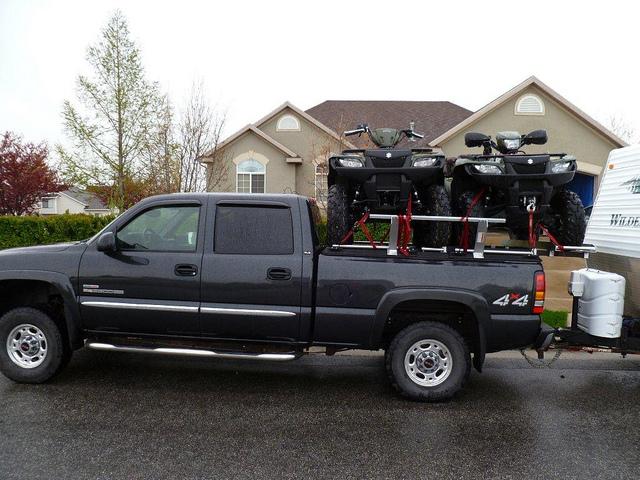What color is the pickup truck?
Quick response, please. Black. What color is the stripe on the side of the truck?
Keep it brief. Silver. What hometown event might this truck have been in?
Quick response, please. Parade. What do they use to unload the quads?
Short answer required. Ramp. What color is the vehicle?
Quick response, please. Black. Is this a new truck?
Be succinct. Yes. Is this a recent model?
Write a very short answer. Yes. What is the truck transporting?
Be succinct. 4 wheelers. What is the truck towing?
Quick response, please. Camper. Are they going camping?
Concise answer only. Yes. Does the truck have a running board?
Be succinct. Yes. What color rims does the truck have?
Concise answer only. Silver. Are the trucks in motion?
Keep it brief. No. Is the truck driving?
Answer briefly. No. How many four wheelers are there?
Answer briefly. 2. What kind of event is this?
Give a very brief answer. Camping. Is there rust on the truck?
Short answer required. No. Is the truck towing a trailer?
Short answer required. Yes. Is this a modern day vehicle?
Concise answer only. Yes. What color are the trees?
Concise answer only. Green and red. What is the condition of the truck?
Short answer required. New. Would these vehicles be considered "classic"?
Quick response, please. No. How many brake lights are in this photo?
Answer briefly. 1. On which side of the vehicle do you access the fuel tank?
Short answer required. Right. What color is this truck?
Give a very brief answer. Black. What color is the truck?
Short answer required. Black. 